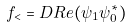Convert formula to latex. <formula><loc_0><loc_0><loc_500><loc_500>f _ { < } = D R e ( \psi _ { 1 } \psi _ { 0 } ^ { \ast } )</formula> 